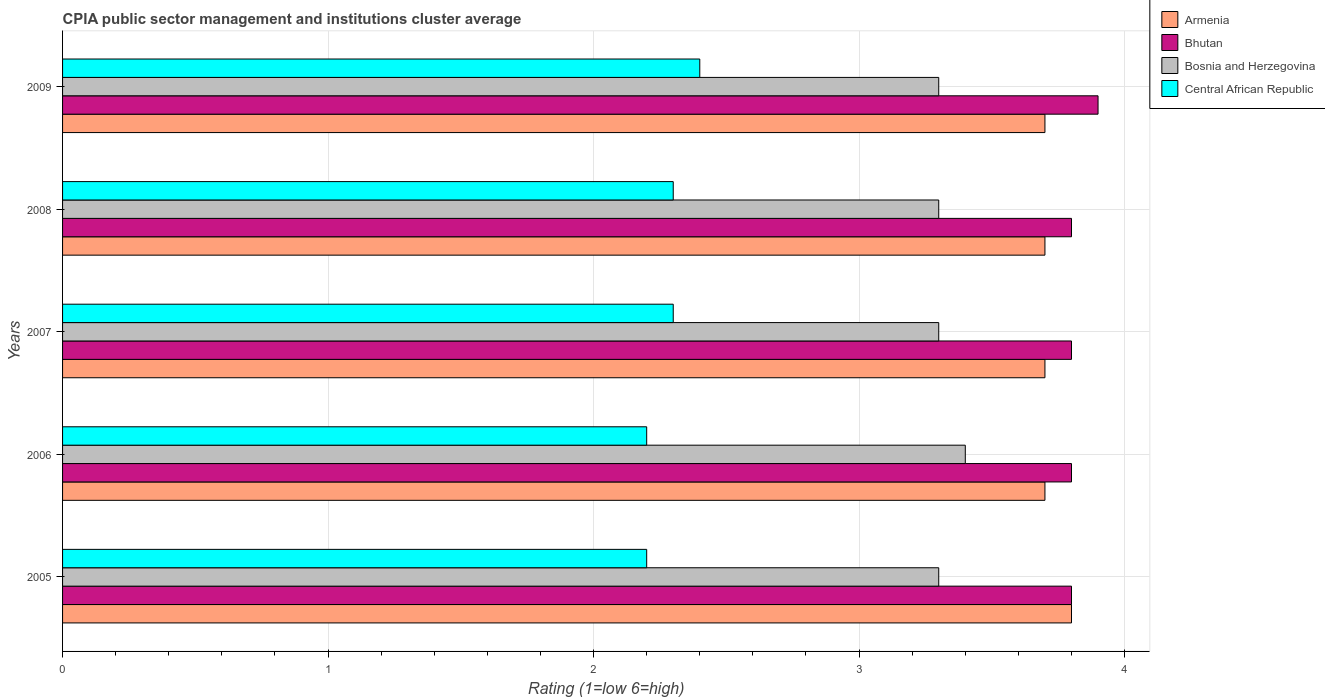How many different coloured bars are there?
Offer a terse response. 4. Are the number of bars per tick equal to the number of legend labels?
Make the answer very short. Yes. Are the number of bars on each tick of the Y-axis equal?
Offer a terse response. Yes. How many bars are there on the 2nd tick from the top?
Your answer should be very brief. 4. How many bars are there on the 2nd tick from the bottom?
Ensure brevity in your answer.  4. What is the label of the 4th group of bars from the top?
Your response must be concise. 2006. In how many cases, is the number of bars for a given year not equal to the number of legend labels?
Your answer should be compact. 0. What is the CPIA rating in Bosnia and Herzegovina in 2005?
Make the answer very short. 3.3. Across all years, what is the maximum CPIA rating in Armenia?
Your answer should be compact. 3.8. In which year was the CPIA rating in Armenia maximum?
Provide a succinct answer. 2005. In which year was the CPIA rating in Central African Republic minimum?
Keep it short and to the point. 2005. What is the total CPIA rating in Bosnia and Herzegovina in the graph?
Your answer should be very brief. 16.6. What is the difference between the CPIA rating in Central African Republic in 2006 and that in 2009?
Offer a very short reply. -0.2. What is the average CPIA rating in Bhutan per year?
Your answer should be very brief. 3.82. In how many years, is the CPIA rating in Central African Republic greater than 3.8 ?
Give a very brief answer. 0. What is the ratio of the CPIA rating in Bosnia and Herzegovina in 2007 to that in 2009?
Provide a succinct answer. 1. Is the difference between the CPIA rating in Bhutan in 2008 and 2009 greater than the difference between the CPIA rating in Central African Republic in 2008 and 2009?
Offer a very short reply. No. What is the difference between the highest and the second highest CPIA rating in Armenia?
Ensure brevity in your answer.  0.1. What is the difference between the highest and the lowest CPIA rating in Central African Republic?
Your answer should be compact. 0.2. Is the sum of the CPIA rating in Bhutan in 2007 and 2009 greater than the maximum CPIA rating in Armenia across all years?
Ensure brevity in your answer.  Yes. Is it the case that in every year, the sum of the CPIA rating in Armenia and CPIA rating in Bosnia and Herzegovina is greater than the sum of CPIA rating in Central African Republic and CPIA rating in Bhutan?
Your answer should be very brief. Yes. What does the 3rd bar from the top in 2009 represents?
Offer a very short reply. Bhutan. What does the 3rd bar from the bottom in 2006 represents?
Keep it short and to the point. Bosnia and Herzegovina. How many years are there in the graph?
Offer a terse response. 5. Does the graph contain any zero values?
Ensure brevity in your answer.  No. Where does the legend appear in the graph?
Provide a short and direct response. Top right. How are the legend labels stacked?
Provide a succinct answer. Vertical. What is the title of the graph?
Give a very brief answer. CPIA public sector management and institutions cluster average. What is the Rating (1=low 6=high) in Armenia in 2005?
Keep it short and to the point. 3.8. What is the Rating (1=low 6=high) in Armenia in 2007?
Provide a succinct answer. 3.7. What is the Rating (1=low 6=high) of Bhutan in 2008?
Your answer should be compact. 3.8. Across all years, what is the minimum Rating (1=low 6=high) in Bhutan?
Your answer should be very brief. 3.8. What is the total Rating (1=low 6=high) in Armenia in the graph?
Offer a very short reply. 18.6. What is the total Rating (1=low 6=high) in Central African Republic in the graph?
Offer a terse response. 11.4. What is the difference between the Rating (1=low 6=high) in Armenia in 2005 and that in 2006?
Make the answer very short. 0.1. What is the difference between the Rating (1=low 6=high) in Bhutan in 2005 and that in 2006?
Keep it short and to the point. 0. What is the difference between the Rating (1=low 6=high) in Bosnia and Herzegovina in 2005 and that in 2006?
Provide a succinct answer. -0.1. What is the difference between the Rating (1=low 6=high) of Bosnia and Herzegovina in 2005 and that in 2007?
Offer a terse response. 0. What is the difference between the Rating (1=low 6=high) of Central African Republic in 2005 and that in 2007?
Your answer should be compact. -0.1. What is the difference between the Rating (1=low 6=high) in Armenia in 2005 and that in 2008?
Offer a terse response. 0.1. What is the difference between the Rating (1=low 6=high) of Central African Republic in 2005 and that in 2008?
Offer a very short reply. -0.1. What is the difference between the Rating (1=low 6=high) of Armenia in 2005 and that in 2009?
Your answer should be compact. 0.1. What is the difference between the Rating (1=low 6=high) in Bosnia and Herzegovina in 2005 and that in 2009?
Your response must be concise. 0. What is the difference between the Rating (1=low 6=high) in Armenia in 2006 and that in 2007?
Offer a terse response. 0. What is the difference between the Rating (1=low 6=high) of Bosnia and Herzegovina in 2006 and that in 2007?
Your response must be concise. 0.1. What is the difference between the Rating (1=low 6=high) of Central African Republic in 2006 and that in 2007?
Give a very brief answer. -0.1. What is the difference between the Rating (1=low 6=high) of Armenia in 2006 and that in 2008?
Offer a terse response. 0. What is the difference between the Rating (1=low 6=high) in Armenia in 2006 and that in 2009?
Ensure brevity in your answer.  0. What is the difference between the Rating (1=low 6=high) of Bosnia and Herzegovina in 2006 and that in 2009?
Provide a short and direct response. 0.1. What is the difference between the Rating (1=low 6=high) in Bosnia and Herzegovina in 2007 and that in 2008?
Your response must be concise. 0. What is the difference between the Rating (1=low 6=high) of Central African Republic in 2007 and that in 2008?
Make the answer very short. 0. What is the difference between the Rating (1=low 6=high) of Bosnia and Herzegovina in 2007 and that in 2009?
Keep it short and to the point. 0. What is the difference between the Rating (1=low 6=high) in Bhutan in 2008 and that in 2009?
Your answer should be compact. -0.1. What is the difference between the Rating (1=low 6=high) of Bosnia and Herzegovina in 2008 and that in 2009?
Provide a short and direct response. 0. What is the difference between the Rating (1=low 6=high) in Central African Republic in 2008 and that in 2009?
Offer a very short reply. -0.1. What is the difference between the Rating (1=low 6=high) in Armenia in 2005 and the Rating (1=low 6=high) in Bosnia and Herzegovina in 2006?
Offer a terse response. 0.4. What is the difference between the Rating (1=low 6=high) of Bhutan in 2005 and the Rating (1=low 6=high) of Central African Republic in 2006?
Your answer should be very brief. 1.6. What is the difference between the Rating (1=low 6=high) in Armenia in 2005 and the Rating (1=low 6=high) in Bosnia and Herzegovina in 2007?
Your answer should be compact. 0.5. What is the difference between the Rating (1=low 6=high) of Armenia in 2005 and the Rating (1=low 6=high) of Central African Republic in 2007?
Provide a succinct answer. 1.5. What is the difference between the Rating (1=low 6=high) of Bhutan in 2005 and the Rating (1=low 6=high) of Bosnia and Herzegovina in 2007?
Provide a succinct answer. 0.5. What is the difference between the Rating (1=low 6=high) of Bhutan in 2005 and the Rating (1=low 6=high) of Central African Republic in 2007?
Give a very brief answer. 1.5. What is the difference between the Rating (1=low 6=high) in Armenia in 2005 and the Rating (1=low 6=high) in Bhutan in 2008?
Provide a short and direct response. 0. What is the difference between the Rating (1=low 6=high) of Armenia in 2005 and the Rating (1=low 6=high) of Central African Republic in 2008?
Provide a short and direct response. 1.5. What is the difference between the Rating (1=low 6=high) of Bhutan in 2005 and the Rating (1=low 6=high) of Central African Republic in 2008?
Offer a terse response. 1.5. What is the difference between the Rating (1=low 6=high) of Bosnia and Herzegovina in 2005 and the Rating (1=low 6=high) of Central African Republic in 2008?
Offer a terse response. 1. What is the difference between the Rating (1=low 6=high) in Armenia in 2005 and the Rating (1=low 6=high) in Bhutan in 2009?
Offer a very short reply. -0.1. What is the difference between the Rating (1=low 6=high) in Armenia in 2005 and the Rating (1=low 6=high) in Bosnia and Herzegovina in 2009?
Your answer should be very brief. 0.5. What is the difference between the Rating (1=low 6=high) in Bhutan in 2005 and the Rating (1=low 6=high) in Bosnia and Herzegovina in 2009?
Ensure brevity in your answer.  0.5. What is the difference between the Rating (1=low 6=high) of Bhutan in 2005 and the Rating (1=low 6=high) of Central African Republic in 2009?
Offer a terse response. 1.4. What is the difference between the Rating (1=low 6=high) of Bosnia and Herzegovina in 2005 and the Rating (1=low 6=high) of Central African Republic in 2009?
Your answer should be very brief. 0.9. What is the difference between the Rating (1=low 6=high) in Armenia in 2006 and the Rating (1=low 6=high) in Bhutan in 2007?
Offer a terse response. -0.1. What is the difference between the Rating (1=low 6=high) of Armenia in 2006 and the Rating (1=low 6=high) of Central African Republic in 2007?
Provide a short and direct response. 1.4. What is the difference between the Rating (1=low 6=high) in Bhutan in 2006 and the Rating (1=low 6=high) in Central African Republic in 2008?
Make the answer very short. 1.5. What is the difference between the Rating (1=low 6=high) of Bosnia and Herzegovina in 2006 and the Rating (1=low 6=high) of Central African Republic in 2008?
Offer a terse response. 1.1. What is the difference between the Rating (1=low 6=high) in Armenia in 2006 and the Rating (1=low 6=high) in Bhutan in 2009?
Your answer should be very brief. -0.2. What is the difference between the Rating (1=low 6=high) of Armenia in 2006 and the Rating (1=low 6=high) of Bosnia and Herzegovina in 2009?
Provide a succinct answer. 0.4. What is the difference between the Rating (1=low 6=high) in Armenia in 2006 and the Rating (1=low 6=high) in Central African Republic in 2009?
Offer a very short reply. 1.3. What is the difference between the Rating (1=low 6=high) in Bosnia and Herzegovina in 2006 and the Rating (1=low 6=high) in Central African Republic in 2009?
Offer a very short reply. 1. What is the difference between the Rating (1=low 6=high) in Armenia in 2007 and the Rating (1=low 6=high) in Bosnia and Herzegovina in 2008?
Provide a succinct answer. 0.4. What is the difference between the Rating (1=low 6=high) of Armenia in 2007 and the Rating (1=low 6=high) of Central African Republic in 2008?
Keep it short and to the point. 1.4. What is the difference between the Rating (1=low 6=high) in Bhutan in 2007 and the Rating (1=low 6=high) in Bosnia and Herzegovina in 2008?
Your answer should be compact. 0.5. What is the difference between the Rating (1=low 6=high) in Bosnia and Herzegovina in 2007 and the Rating (1=low 6=high) in Central African Republic in 2008?
Provide a short and direct response. 1. What is the difference between the Rating (1=low 6=high) of Armenia in 2007 and the Rating (1=low 6=high) of Bhutan in 2009?
Provide a succinct answer. -0.2. What is the difference between the Rating (1=low 6=high) of Bhutan in 2007 and the Rating (1=low 6=high) of Central African Republic in 2009?
Offer a very short reply. 1.4. What is the difference between the Rating (1=low 6=high) of Bosnia and Herzegovina in 2007 and the Rating (1=low 6=high) of Central African Republic in 2009?
Provide a short and direct response. 0.9. What is the difference between the Rating (1=low 6=high) in Armenia in 2008 and the Rating (1=low 6=high) in Central African Republic in 2009?
Ensure brevity in your answer.  1.3. What is the difference between the Rating (1=low 6=high) of Bhutan in 2008 and the Rating (1=low 6=high) of Bosnia and Herzegovina in 2009?
Your answer should be compact. 0.5. What is the difference between the Rating (1=low 6=high) of Bosnia and Herzegovina in 2008 and the Rating (1=low 6=high) of Central African Republic in 2009?
Provide a short and direct response. 0.9. What is the average Rating (1=low 6=high) in Armenia per year?
Your response must be concise. 3.72. What is the average Rating (1=low 6=high) in Bhutan per year?
Offer a terse response. 3.82. What is the average Rating (1=low 6=high) in Bosnia and Herzegovina per year?
Provide a short and direct response. 3.32. What is the average Rating (1=low 6=high) of Central African Republic per year?
Your response must be concise. 2.28. In the year 2005, what is the difference between the Rating (1=low 6=high) of Bhutan and Rating (1=low 6=high) of Central African Republic?
Keep it short and to the point. 1.6. In the year 2006, what is the difference between the Rating (1=low 6=high) of Armenia and Rating (1=low 6=high) of Bhutan?
Keep it short and to the point. -0.1. In the year 2006, what is the difference between the Rating (1=low 6=high) in Bhutan and Rating (1=low 6=high) in Bosnia and Herzegovina?
Offer a terse response. 0.4. In the year 2006, what is the difference between the Rating (1=low 6=high) of Bhutan and Rating (1=low 6=high) of Central African Republic?
Make the answer very short. 1.6. In the year 2006, what is the difference between the Rating (1=low 6=high) in Bosnia and Herzegovina and Rating (1=low 6=high) in Central African Republic?
Provide a succinct answer. 1.2. In the year 2007, what is the difference between the Rating (1=low 6=high) in Armenia and Rating (1=low 6=high) in Bhutan?
Ensure brevity in your answer.  -0.1. In the year 2007, what is the difference between the Rating (1=low 6=high) of Armenia and Rating (1=low 6=high) of Bosnia and Herzegovina?
Your answer should be very brief. 0.4. In the year 2007, what is the difference between the Rating (1=low 6=high) of Armenia and Rating (1=low 6=high) of Central African Republic?
Offer a terse response. 1.4. In the year 2008, what is the difference between the Rating (1=low 6=high) of Armenia and Rating (1=low 6=high) of Bhutan?
Give a very brief answer. -0.1. In the year 2008, what is the difference between the Rating (1=low 6=high) in Armenia and Rating (1=low 6=high) in Bosnia and Herzegovina?
Provide a short and direct response. 0.4. In the year 2008, what is the difference between the Rating (1=low 6=high) of Armenia and Rating (1=low 6=high) of Central African Republic?
Give a very brief answer. 1.4. In the year 2008, what is the difference between the Rating (1=low 6=high) in Bhutan and Rating (1=low 6=high) in Central African Republic?
Provide a short and direct response. 1.5. In the year 2008, what is the difference between the Rating (1=low 6=high) of Bosnia and Herzegovina and Rating (1=low 6=high) of Central African Republic?
Provide a succinct answer. 1. In the year 2009, what is the difference between the Rating (1=low 6=high) in Armenia and Rating (1=low 6=high) in Bosnia and Herzegovina?
Your answer should be very brief. 0.4. In the year 2009, what is the difference between the Rating (1=low 6=high) of Bosnia and Herzegovina and Rating (1=low 6=high) of Central African Republic?
Your answer should be compact. 0.9. What is the ratio of the Rating (1=low 6=high) in Armenia in 2005 to that in 2006?
Your response must be concise. 1.03. What is the ratio of the Rating (1=low 6=high) in Bhutan in 2005 to that in 2006?
Provide a succinct answer. 1. What is the ratio of the Rating (1=low 6=high) of Bosnia and Herzegovina in 2005 to that in 2006?
Your answer should be compact. 0.97. What is the ratio of the Rating (1=low 6=high) of Central African Republic in 2005 to that in 2007?
Give a very brief answer. 0.96. What is the ratio of the Rating (1=low 6=high) of Bhutan in 2005 to that in 2008?
Provide a succinct answer. 1. What is the ratio of the Rating (1=low 6=high) in Central African Republic in 2005 to that in 2008?
Offer a terse response. 0.96. What is the ratio of the Rating (1=low 6=high) in Armenia in 2005 to that in 2009?
Make the answer very short. 1.03. What is the ratio of the Rating (1=low 6=high) in Bhutan in 2005 to that in 2009?
Your response must be concise. 0.97. What is the ratio of the Rating (1=low 6=high) in Central African Republic in 2005 to that in 2009?
Your answer should be very brief. 0.92. What is the ratio of the Rating (1=low 6=high) in Armenia in 2006 to that in 2007?
Offer a terse response. 1. What is the ratio of the Rating (1=low 6=high) of Bosnia and Herzegovina in 2006 to that in 2007?
Offer a very short reply. 1.03. What is the ratio of the Rating (1=low 6=high) in Central African Republic in 2006 to that in 2007?
Your response must be concise. 0.96. What is the ratio of the Rating (1=low 6=high) of Armenia in 2006 to that in 2008?
Your answer should be very brief. 1. What is the ratio of the Rating (1=low 6=high) of Bhutan in 2006 to that in 2008?
Your response must be concise. 1. What is the ratio of the Rating (1=low 6=high) of Bosnia and Herzegovina in 2006 to that in 2008?
Ensure brevity in your answer.  1.03. What is the ratio of the Rating (1=low 6=high) of Central African Republic in 2006 to that in 2008?
Make the answer very short. 0.96. What is the ratio of the Rating (1=low 6=high) in Armenia in 2006 to that in 2009?
Offer a very short reply. 1. What is the ratio of the Rating (1=low 6=high) of Bhutan in 2006 to that in 2009?
Make the answer very short. 0.97. What is the ratio of the Rating (1=low 6=high) of Bosnia and Herzegovina in 2006 to that in 2009?
Offer a terse response. 1.03. What is the ratio of the Rating (1=low 6=high) of Central African Republic in 2006 to that in 2009?
Your answer should be compact. 0.92. What is the ratio of the Rating (1=low 6=high) in Bhutan in 2007 to that in 2008?
Keep it short and to the point. 1. What is the ratio of the Rating (1=low 6=high) in Bosnia and Herzegovina in 2007 to that in 2008?
Your answer should be compact. 1. What is the ratio of the Rating (1=low 6=high) in Central African Republic in 2007 to that in 2008?
Ensure brevity in your answer.  1. What is the ratio of the Rating (1=low 6=high) in Armenia in 2007 to that in 2009?
Offer a very short reply. 1. What is the ratio of the Rating (1=low 6=high) in Bhutan in 2007 to that in 2009?
Make the answer very short. 0.97. What is the ratio of the Rating (1=low 6=high) in Bhutan in 2008 to that in 2009?
Give a very brief answer. 0.97. What is the ratio of the Rating (1=low 6=high) in Central African Republic in 2008 to that in 2009?
Keep it short and to the point. 0.96. What is the difference between the highest and the second highest Rating (1=low 6=high) of Armenia?
Offer a terse response. 0.1. What is the difference between the highest and the second highest Rating (1=low 6=high) in Central African Republic?
Make the answer very short. 0.1. What is the difference between the highest and the lowest Rating (1=low 6=high) of Bhutan?
Your response must be concise. 0.1. What is the difference between the highest and the lowest Rating (1=low 6=high) in Bosnia and Herzegovina?
Offer a very short reply. 0.1. What is the difference between the highest and the lowest Rating (1=low 6=high) in Central African Republic?
Make the answer very short. 0.2. 